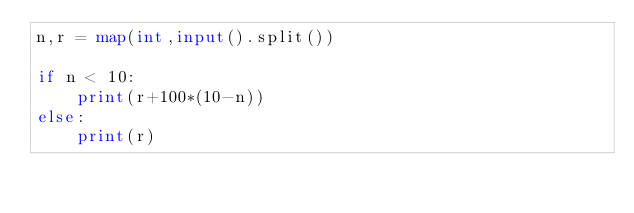<code> <loc_0><loc_0><loc_500><loc_500><_Python_>n,r = map(int,input().split())

if n < 10:
    print(r+100*(10-n))
else:
    print(r)</code> 